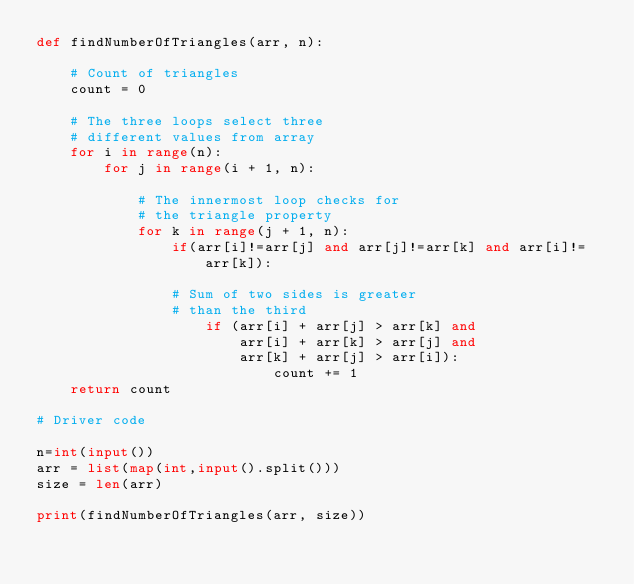<code> <loc_0><loc_0><loc_500><loc_500><_Python_>def findNumberOfTriangles(arr, n): 
      
    # Count of triangles 
    count = 0
      
    # The three loops select three 
    # different values from array 
    for i in range(n): 
        for j in range(i + 1, n): 
              
            # The innermost loop checks for 
            # the triangle property 
            for k in range(j + 1, n): 
                if(arr[i]!=arr[j] and arr[j]!=arr[k] and arr[i]!=arr[k]):
                    
                # Sum of two sides is greater 
                # than the third 
                    if (arr[i] + arr[j] > arr[k] and 
                        arr[i] + arr[k] > arr[j] and 
                        arr[k] + arr[j] > arr[i]): 
                            count += 1
    return count 
  
# Driver code 

n=int(input())
arr = list(map(int,input().split()))
size = len(arr) 
  
print(findNumberOfTriangles(arr, size)) 
  </code> 